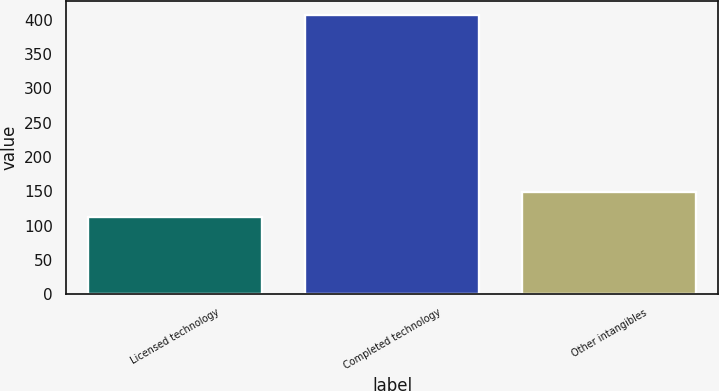Convert chart to OTSL. <chart><loc_0><loc_0><loc_500><loc_500><bar_chart><fcel>Licensed technology<fcel>Completed technology<fcel>Other intangibles<nl><fcel>112<fcel>407<fcel>149<nl></chart> 